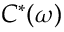Convert formula to latex. <formula><loc_0><loc_0><loc_500><loc_500>C ^ { * } ( \omega )</formula> 